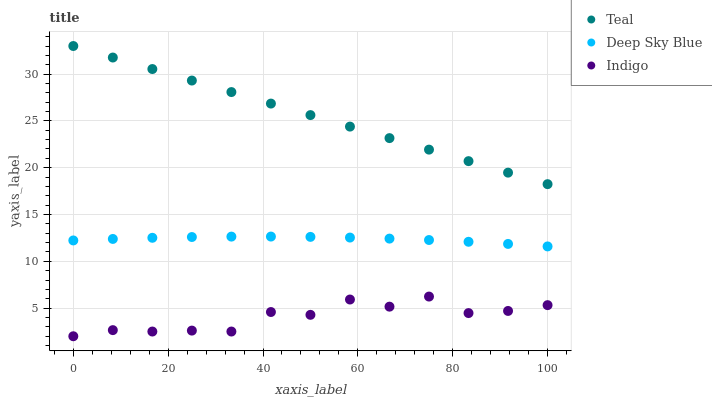Does Indigo have the minimum area under the curve?
Answer yes or no. Yes. Does Teal have the maximum area under the curve?
Answer yes or no. Yes. Does Deep Sky Blue have the minimum area under the curve?
Answer yes or no. No. Does Deep Sky Blue have the maximum area under the curve?
Answer yes or no. No. Is Teal the smoothest?
Answer yes or no. Yes. Is Indigo the roughest?
Answer yes or no. Yes. Is Deep Sky Blue the smoothest?
Answer yes or no. No. Is Deep Sky Blue the roughest?
Answer yes or no. No. Does Indigo have the lowest value?
Answer yes or no. Yes. Does Deep Sky Blue have the lowest value?
Answer yes or no. No. Does Teal have the highest value?
Answer yes or no. Yes. Does Deep Sky Blue have the highest value?
Answer yes or no. No. Is Indigo less than Deep Sky Blue?
Answer yes or no. Yes. Is Teal greater than Deep Sky Blue?
Answer yes or no. Yes. Does Indigo intersect Deep Sky Blue?
Answer yes or no. No. 